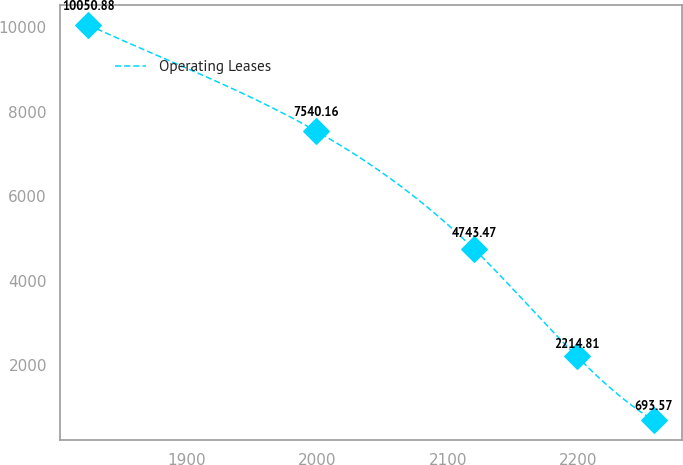Convert chart to OTSL. <chart><loc_0><loc_0><loc_500><loc_500><line_chart><ecel><fcel>Operating Leases<nl><fcel>1824.97<fcel>10050.9<nl><fcel>1999.34<fcel>7540.16<nl><fcel>2120.29<fcel>4743.47<nl><fcel>2198.61<fcel>2214.81<nl><fcel>2257.8<fcel>693.57<nl></chart> 